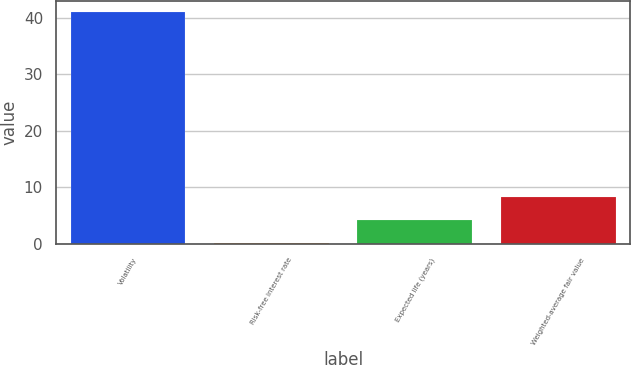<chart> <loc_0><loc_0><loc_500><loc_500><bar_chart><fcel>Volatility<fcel>Risk-free interest rate<fcel>Expected life (years)<fcel>Weighted-average fair value<nl><fcel>41<fcel>0.2<fcel>4.28<fcel>8.36<nl></chart> 